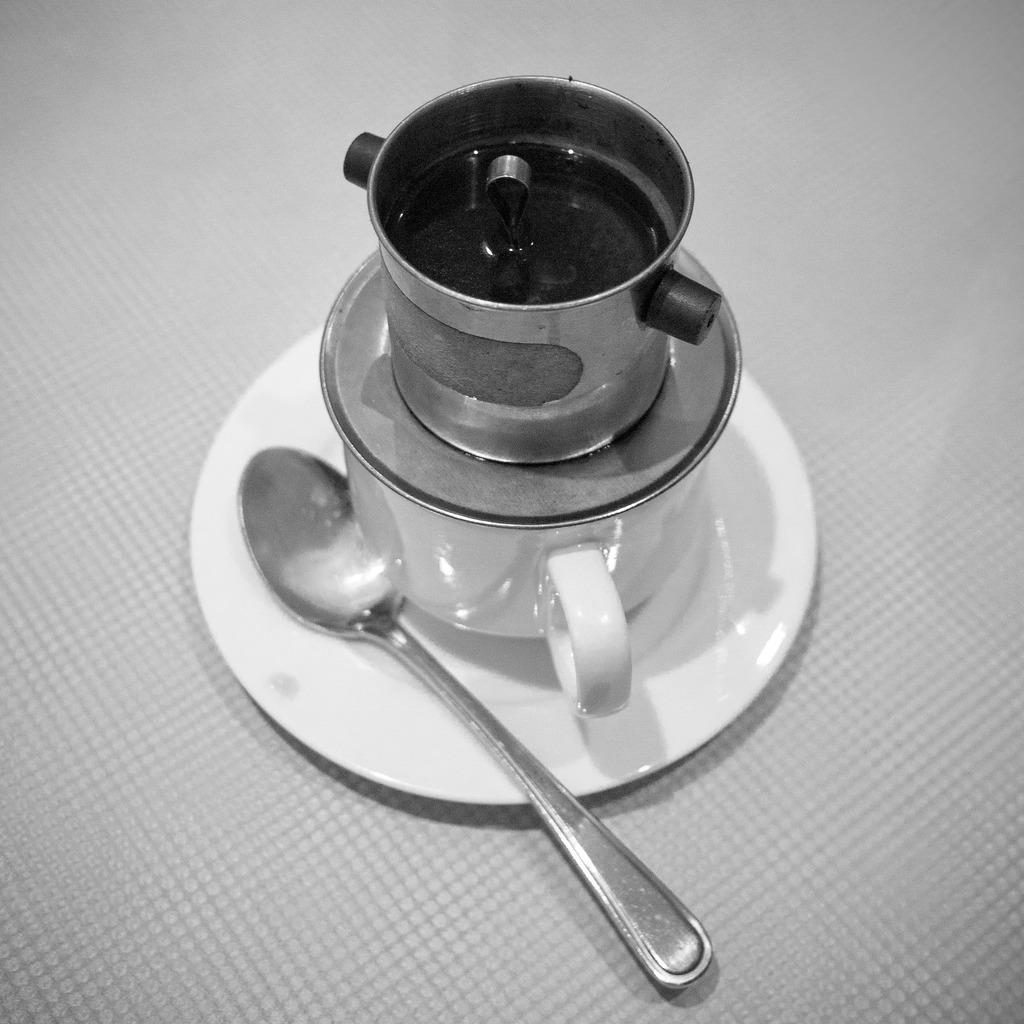Describe this image in one or two sentences. In this image we can see a bowl on the cup, which is on the saucer, there is a spoon, which are on the table, also the picture is taken in black and white mode. 